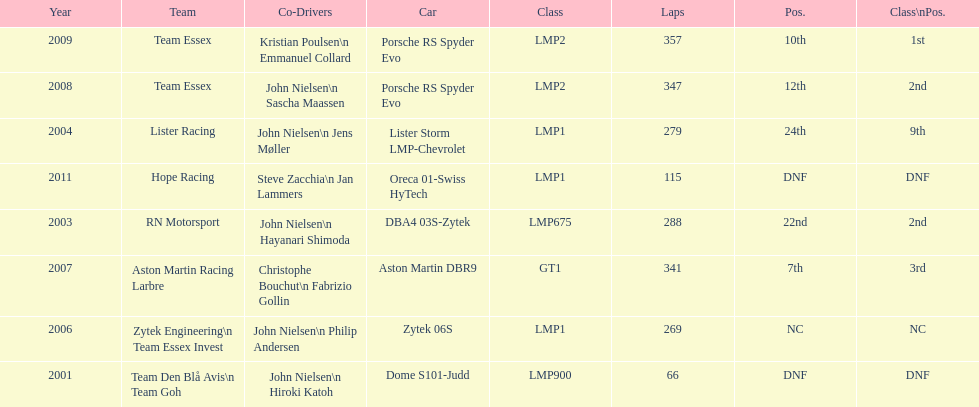In 2008, and during what other year, was casper elgaard a member of team essex at the 24 hours of le mans? 2009. Would you be able to parse every entry in this table? {'header': ['Year', 'Team', 'Co-Drivers', 'Car', 'Class', 'Laps', 'Pos.', 'Class\\nPos.'], 'rows': [['2009', 'Team Essex', 'Kristian Poulsen\\n Emmanuel Collard', 'Porsche RS Spyder Evo', 'LMP2', '357', '10th', '1st'], ['2008', 'Team Essex', 'John Nielsen\\n Sascha Maassen', 'Porsche RS Spyder Evo', 'LMP2', '347', '12th', '2nd'], ['2004', 'Lister Racing', 'John Nielsen\\n Jens Møller', 'Lister Storm LMP-Chevrolet', 'LMP1', '279', '24th', '9th'], ['2011', 'Hope Racing', 'Steve Zacchia\\n Jan Lammers', 'Oreca 01-Swiss HyTech', 'LMP1', '115', 'DNF', 'DNF'], ['2003', 'RN Motorsport', 'John Nielsen\\n Hayanari Shimoda', 'DBA4 03S-Zytek', 'LMP675', '288', '22nd', '2nd'], ['2007', 'Aston Martin Racing Larbre', 'Christophe Bouchut\\n Fabrizio Gollin', 'Aston Martin DBR9', 'GT1', '341', '7th', '3rd'], ['2006', 'Zytek Engineering\\n Team Essex Invest', 'John Nielsen\\n Philip Andersen', 'Zytek 06S', 'LMP1', '269', 'NC', 'NC'], ['2001', 'Team Den Blå Avis\\n Team Goh', 'John Nielsen\\n Hiroki Katoh', 'Dome S101-Judd', 'LMP900', '66', 'DNF', 'DNF']]} 